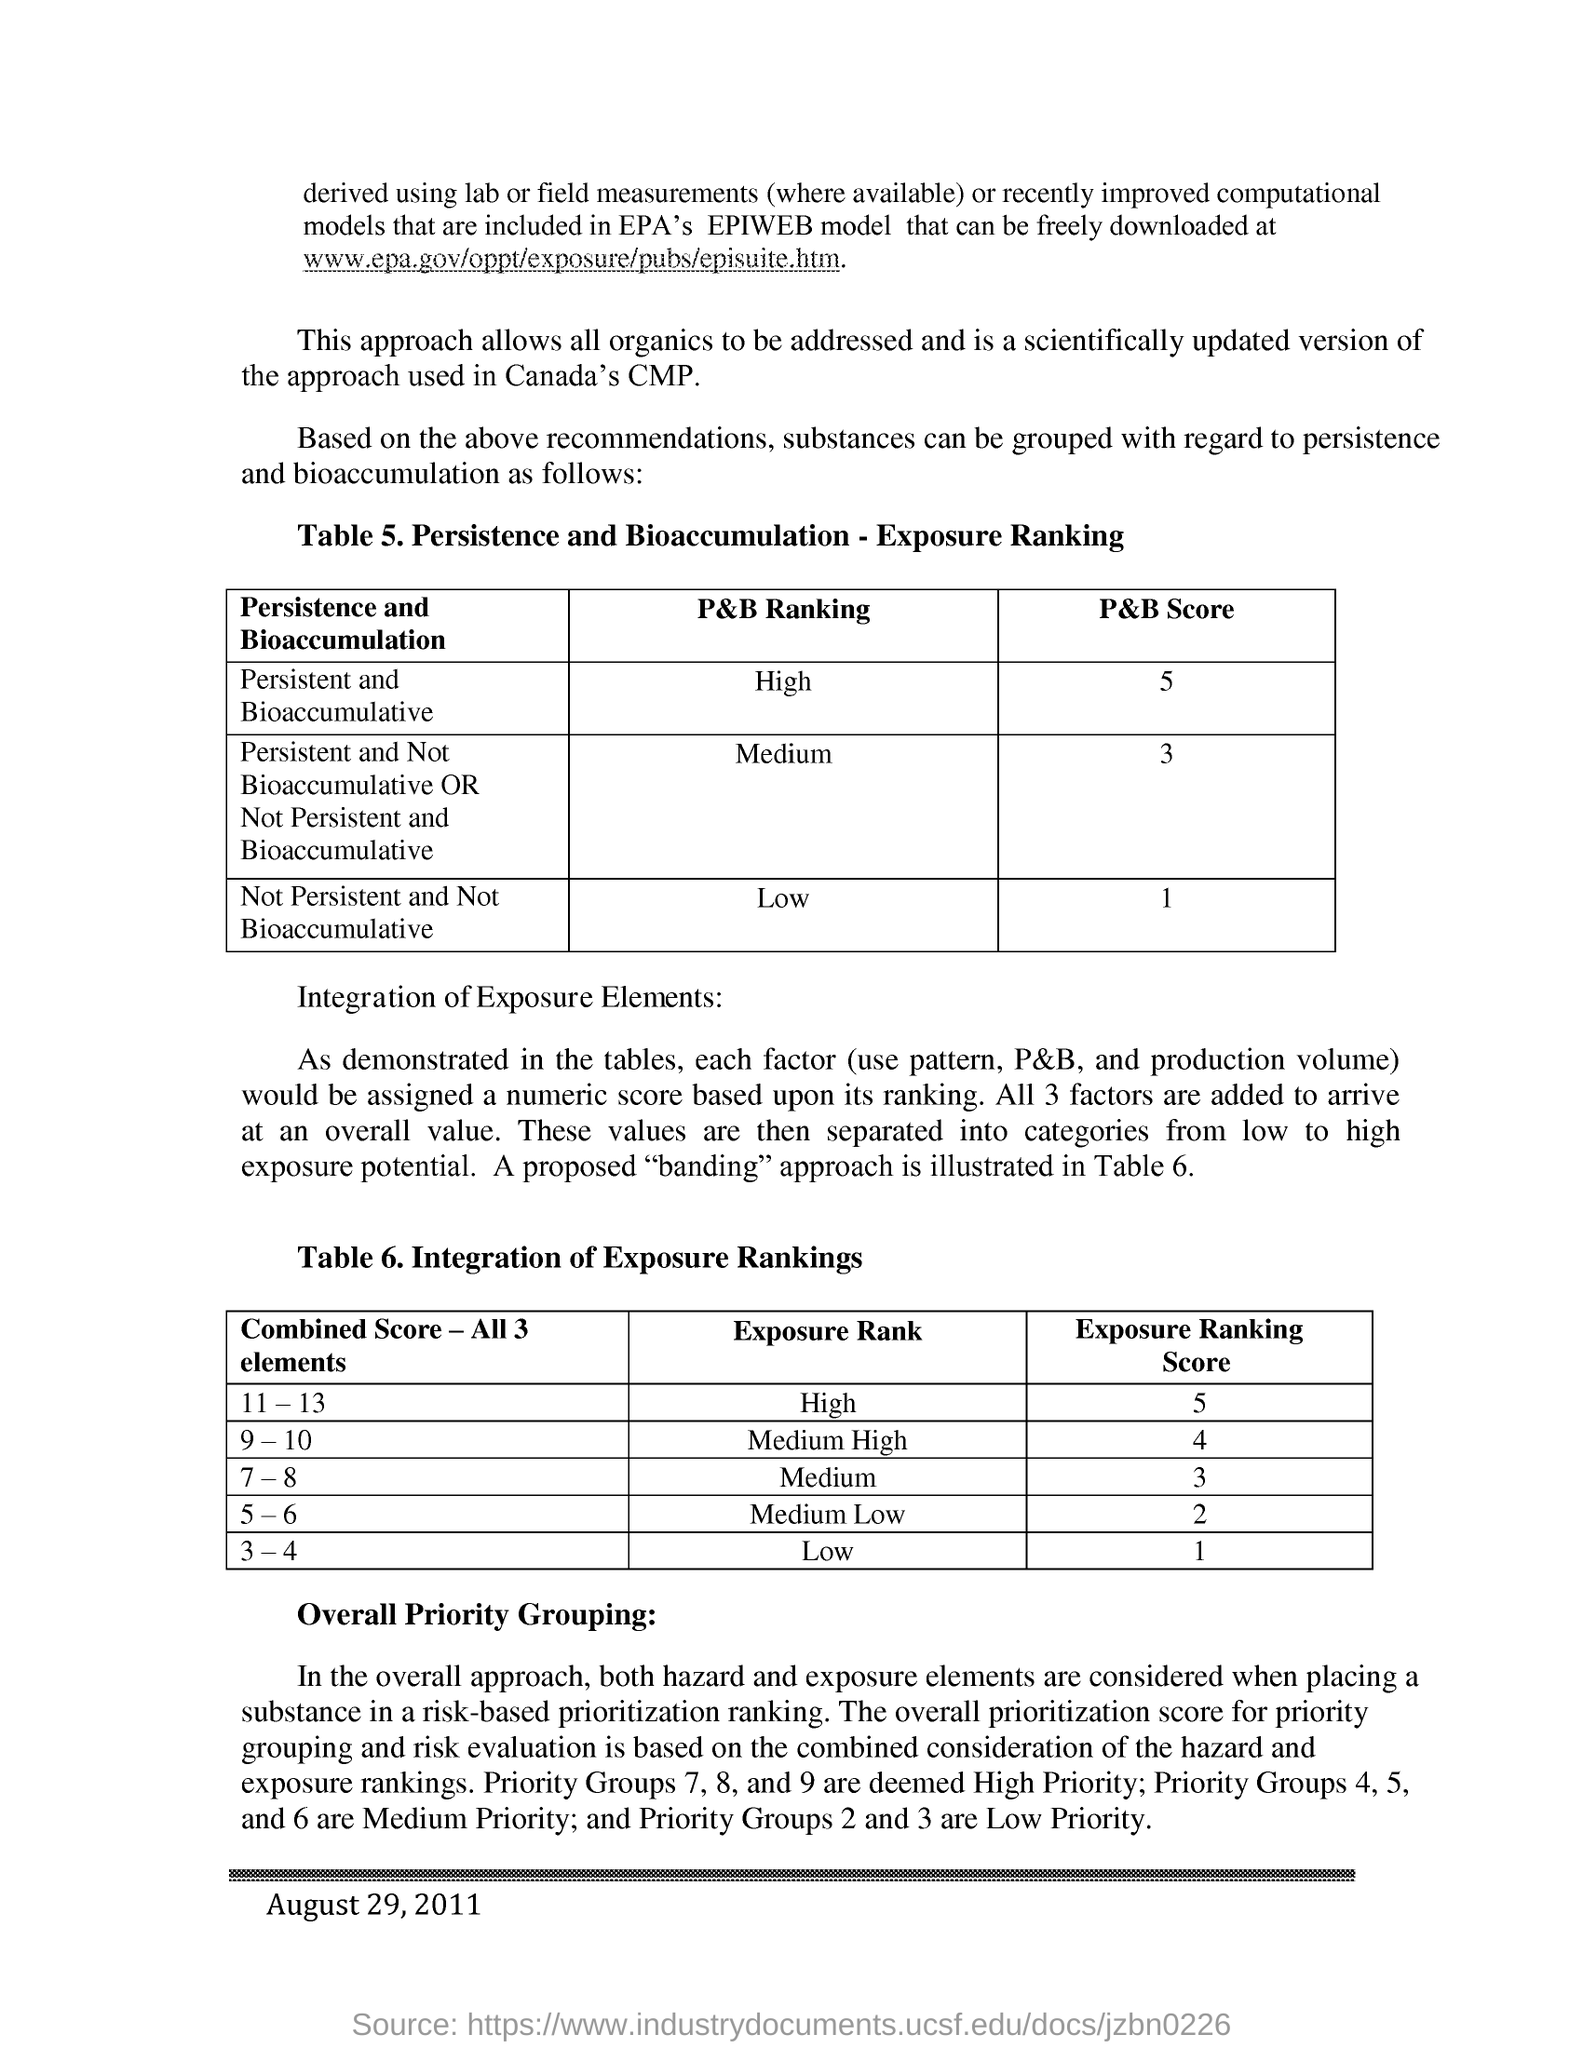What is the p&b score for persistent and bioaccumulative
Keep it short and to the point. 5. What is the p&b ranking for not persistent and not bioaccumulative
Give a very brief answer. Low. What is the exposure rank for the combined score-all 3 elements 11-13
Ensure brevity in your answer.  High. Which priority groups are deemed as  high priority groups?
Give a very brief answer. Priority groups 7,8, and 9. Which priority groups are deemed as medium priority groups?
Provide a short and direct response. Priority groups 4,5, and 6. Which priority groups are deemed as low priority groups ?
Ensure brevity in your answer.  Priority groups 2 and 3. In which year this data was published ?
Offer a very short reply. 2011. 